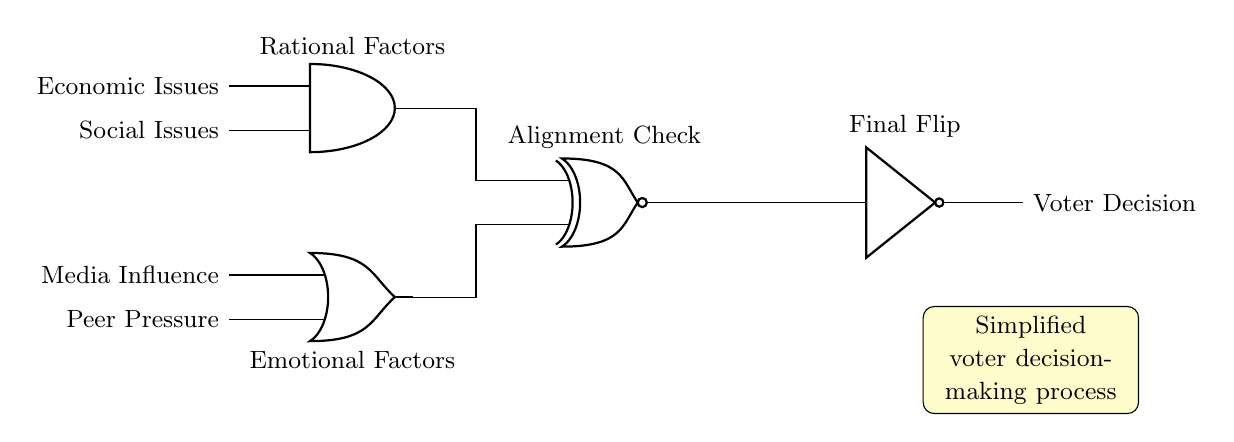What type of logic gate is used at the beginning of this circuit? The first gate in the circuit is an AND gate, which is used to combine the input signals of economic and social issues. This is indicated by the label on the diagram and its position in the circuit.
Answer: AND What are the inputs for the OR gate? The OR gate takes two inputs: media influence and peer pressure. This can be determined by looking at the labels connected to the input terminals of the OR gate in the diagram.
Answer: Media influence and peer pressure What does the XNOR gate signify in this circuit? The XNOR gate indicates an alignment check, which means it compares the output of the AND gate (rational factors) and the OR gate (emotional factors). If both inputs are the same, it signifies alignment in decision making. This is shown by the label above the gate in the circuit.
Answer: Alignment check What happens at the NOT gate? The NOT gate inverts the output of the XNOR gate. If the output is true (aligned), the NOT gate makes it false (decision against). The label above the NOT gate indicates that it performs a final flip on the decision.
Answer: Final flip What is the final output of this circuit? The output from the NOT gate represents the voter decision. The diagram indicates that this is the concluding result of the entire circuit’s processes, confirmed by the label on the right side of the NOT gate.
Answer: Voter decision 